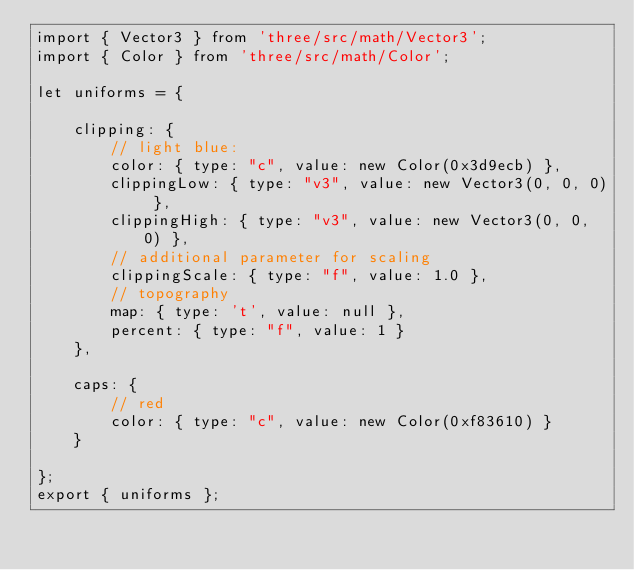Convert code to text. <code><loc_0><loc_0><loc_500><loc_500><_JavaScript_>import { Vector3 } from 'three/src/math/Vector3';
import { Color } from 'three/src/math/Color';

let uniforms = {

    clipping: {
        // light blue:
        color: { type: "c", value: new Color(0x3d9ecb) },
        clippingLow: { type: "v3", value: new Vector3(0, 0, 0) },
        clippingHigh: { type: "v3", value: new Vector3(0, 0, 0) },
        // additional parameter for scaling
        clippingScale: { type: "f", value: 1.0 },
        // topography
        map: { type: 't', value: null },
        percent: { type: "f", value: 1 }
    },

    caps: {
        // red
        color: { type: "c", value: new Color(0xf83610) }
    }

};
export { uniforms };</code> 